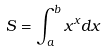Convert formula to latex. <formula><loc_0><loc_0><loc_500><loc_500>S = \int _ { a } ^ { b } x ^ { x } d x</formula> 